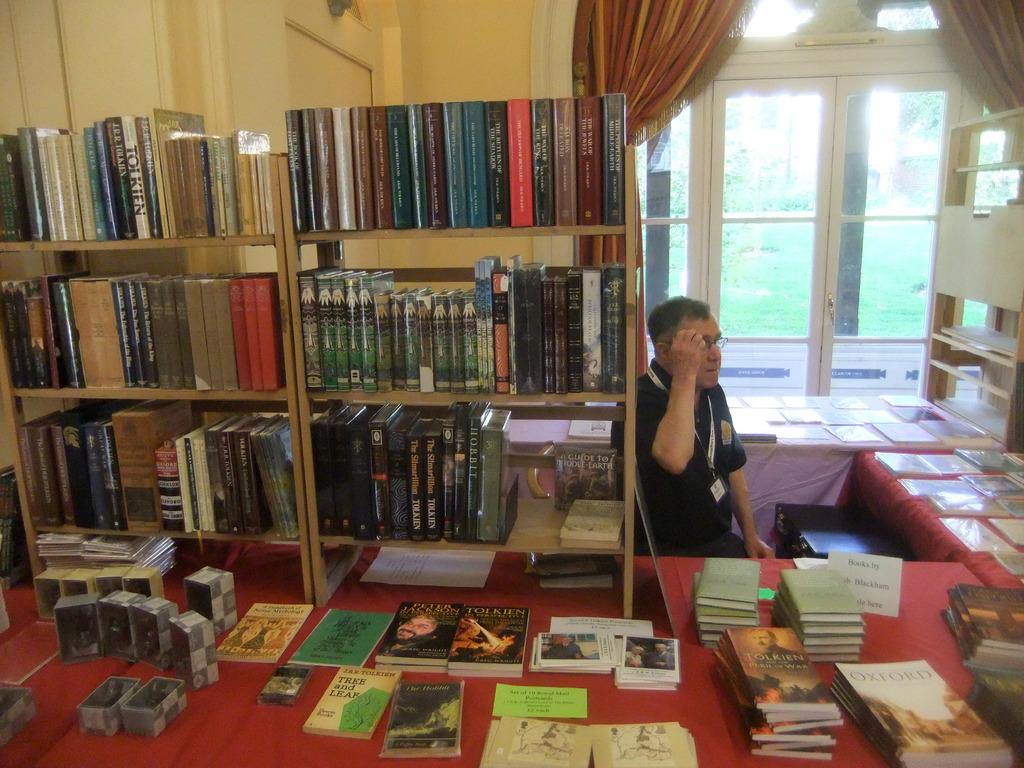<image>
Write a terse but informative summary of the picture. Among the books on this table is one by Tolkien. 